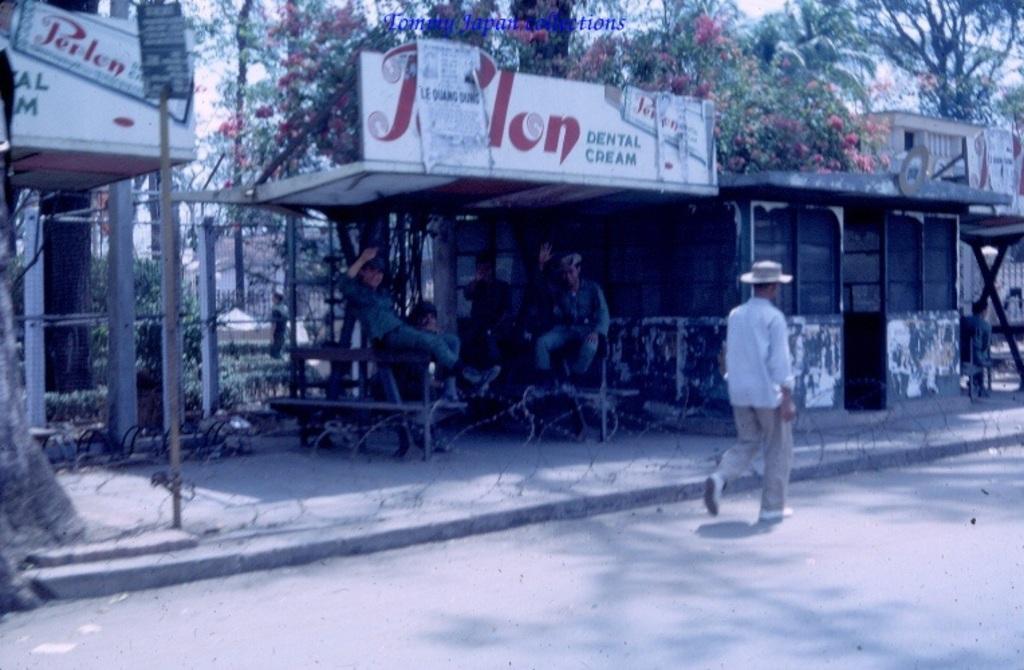Can you describe this image briefly? In this picture we can see a man is walking, there are buildings in the background, we can see benches and a hoarding in the middle, there are some people sitting on benches, on the left side there is a pole and a board, we can also see fencing on the left side, in the background there are some trees, we can see some text at the top of the picture. 